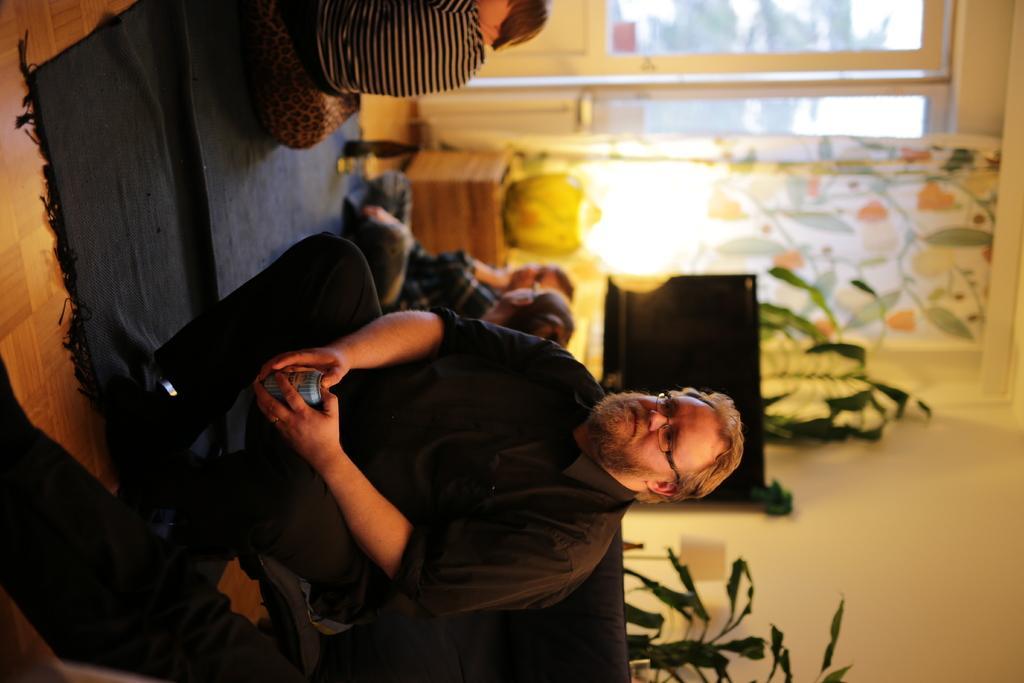Can you describe this image briefly? At the bottom there is a person sitting in a chair, behind him there is a house plant. In the background there are kids sitting on the floor. On the right there are windows, curtain, lamp, desk and television. 